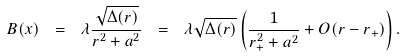<formula> <loc_0><loc_0><loc_500><loc_500>B ( x ) \ = \ \lambda \frac { \sqrt { \Delta ( r ) } } { r ^ { 2 } + a ^ { 2 } } \ = \ \lambda \sqrt { \Delta ( r ) } \left ( \frac { 1 } { r _ { + } ^ { 2 } + a ^ { 2 } } + O ( r - r _ { + } ) \right ) .</formula> 